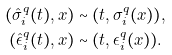<formula> <loc_0><loc_0><loc_500><loc_500>( \hat { \sigma } _ { i } ^ { q } ( t ) , x ) & \sim ( t , \sigma _ { i } ^ { q } ( x ) ) , \\ ( \hat { \epsilon } _ { i } ^ { q } ( t ) , x ) & \sim ( t , \epsilon _ { i } ^ { q } ( x ) ) .</formula> 